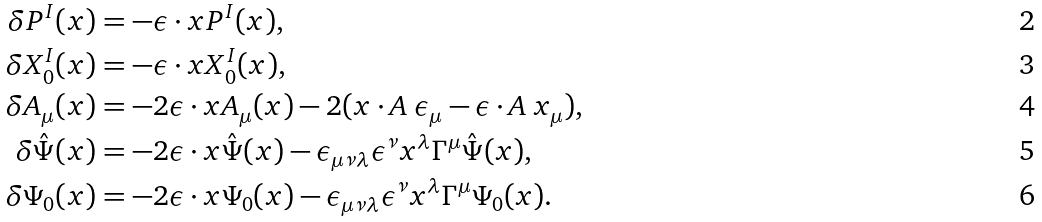Convert formula to latex. <formula><loc_0><loc_0><loc_500><loc_500>\delta P ^ { I } ( x ) & = - \epsilon \cdot x P ^ { I } ( x ) , \\ \delta X _ { 0 } ^ { I } ( x ) & = - \epsilon \cdot x X _ { 0 } ^ { I } ( x ) , \\ \delta A _ { \mu } ( x ) & = - 2 \epsilon \cdot x A _ { \mu } ( x ) - 2 ( x \cdot A \ \epsilon _ { \mu } - \epsilon \cdot A \ x _ { \mu } ) , \\ \delta \hat { \Psi } ( x ) & = - 2 \epsilon \cdot x \hat { \Psi } ( x ) - \epsilon _ { \mu \nu \lambda } \epsilon ^ { \nu } x ^ { \lambda } \Gamma ^ { \mu } \hat { \Psi } ( x ) , \\ \delta \Psi _ { 0 } ( x ) & = - 2 \epsilon \cdot x \Psi _ { 0 } ( x ) - \epsilon _ { \mu \nu \lambda } \epsilon ^ { \nu } x ^ { \lambda } \Gamma ^ { \mu } \Psi _ { 0 } ( x ) .</formula> 